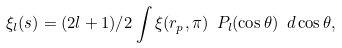Convert formula to latex. <formula><loc_0><loc_0><loc_500><loc_500>\xi _ { l } ( s ) = ( 2 l + 1 ) / 2 \int { \xi ( r _ { p } , \pi ) \ P _ { l } ( \cos \theta ) \ d \cos \theta } ,</formula> 